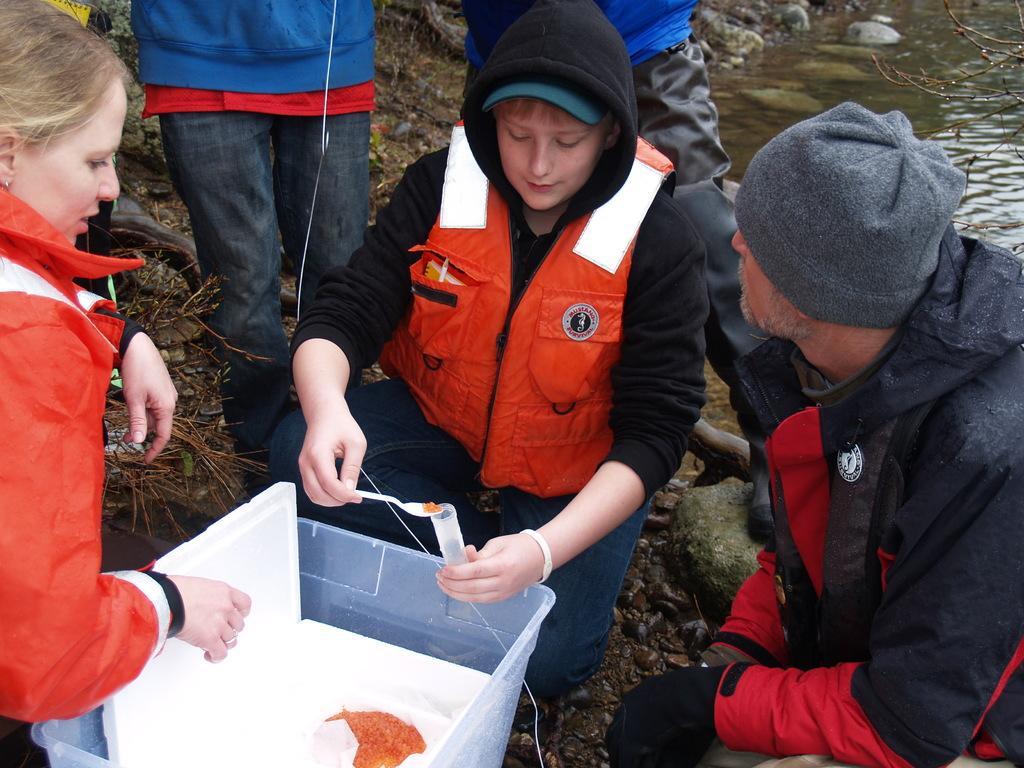In one or two sentences, can you explain what this image depicts? In this image there is a person holding the tube and a spoon. In front of him there is a tub. There is some object inside the tub. Beside him there are a few other people. Behind them there is water. There are rocks. 